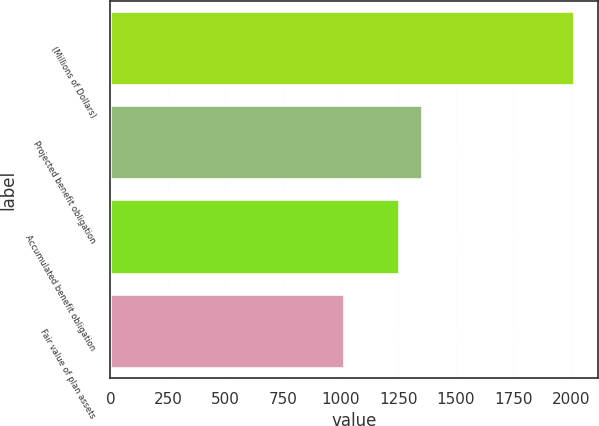Convert chart to OTSL. <chart><loc_0><loc_0><loc_500><loc_500><bar_chart><fcel>(Millions of Dollars)<fcel>Projected benefit obligation<fcel>Accumulated benefit obligation<fcel>Fair value of plan assets<nl><fcel>2018<fcel>1357.33<fcel>1257.6<fcel>1020.7<nl></chart> 